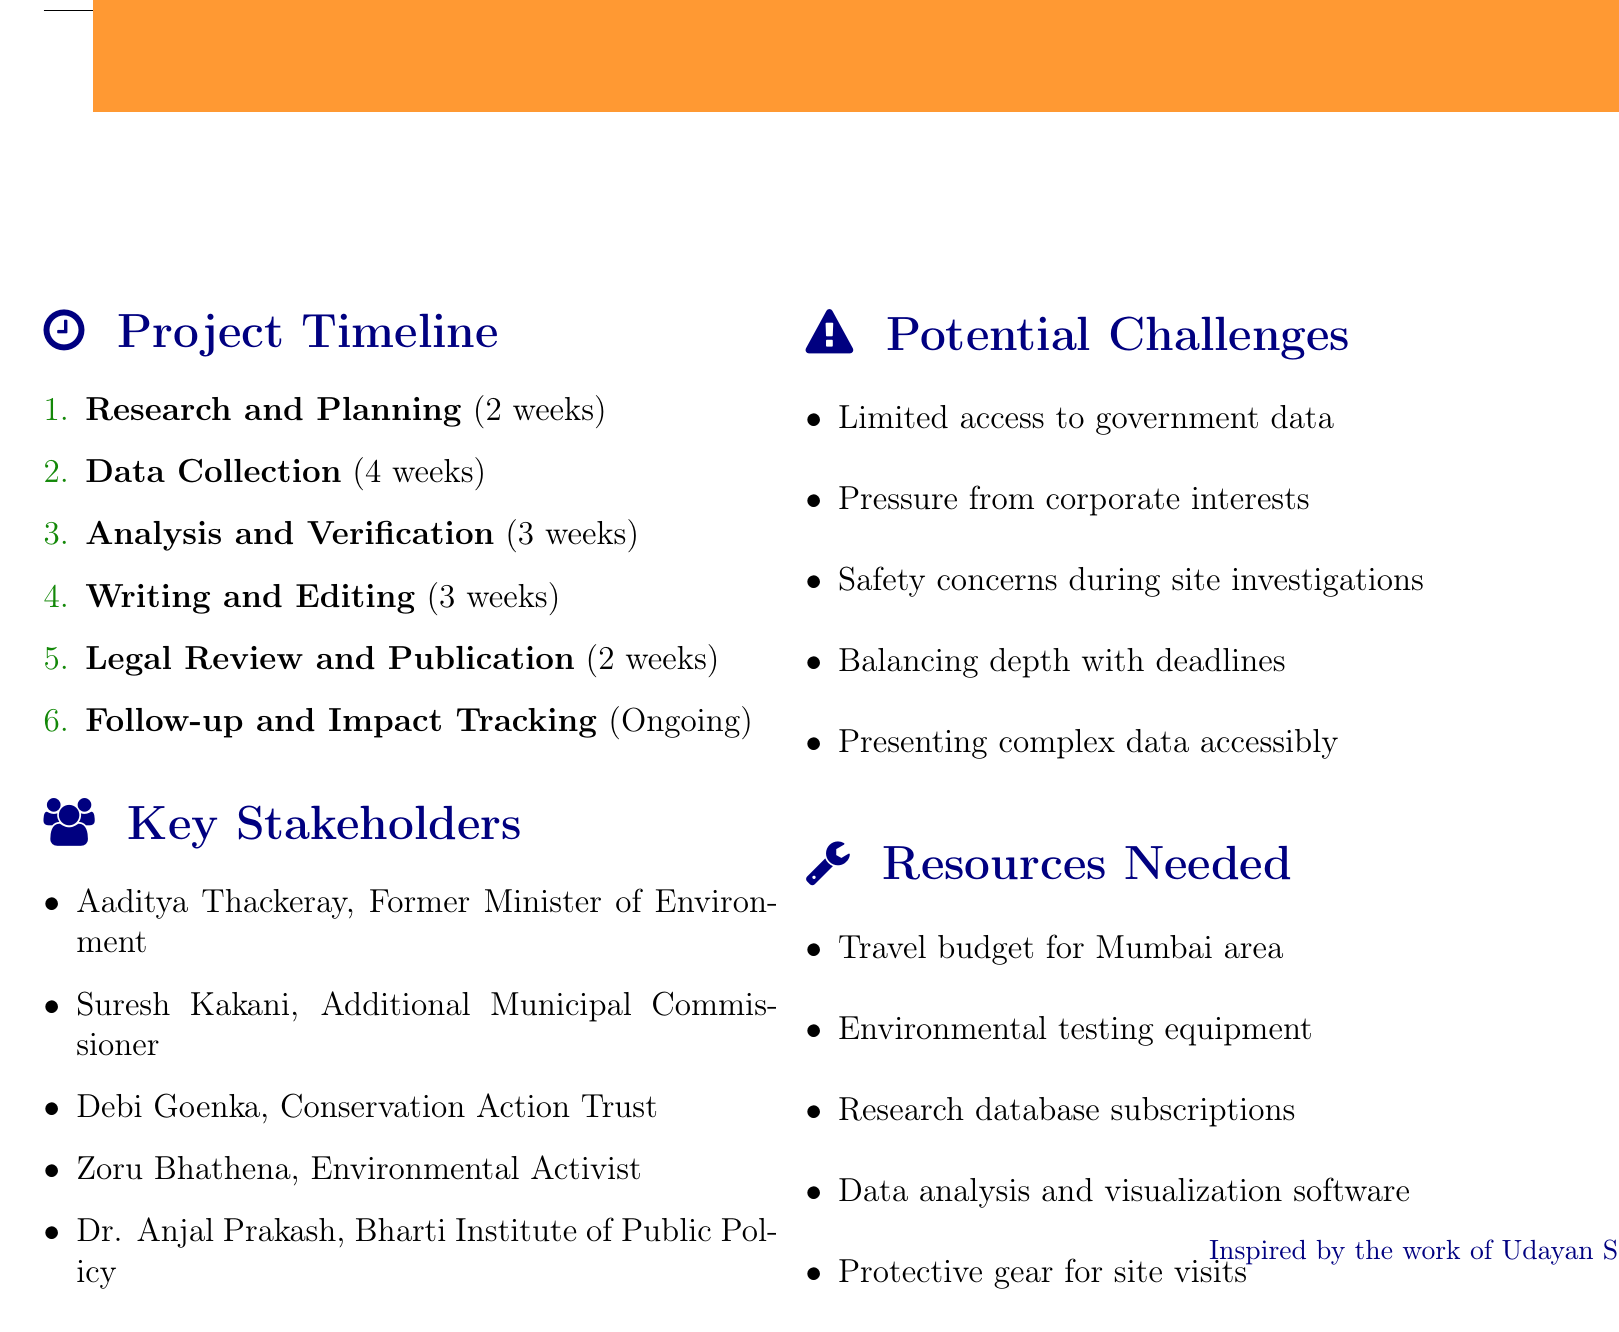what is the duration of the Research and Planning phase? The duration of the Research and Planning phase is mentioned in the document as 2 weeks.
Answer: 2 weeks how many weeks is allocated for Data Collection? The Data Collection phase is allocated 4 weeks as specified in the timeline.
Answer: 4 weeks who is a key stakeholder and an Executive Trustee of the Conservation Action Trust? The document lists Debi Goenka as a key stakeholder who is the Executive Trustee of the Conservation Action Trust.
Answer: Debi Goenka what is one potential challenge mentioned in the document? The document lists multiple potential challenges; one of them includes limited access to government data.
Answer: Limited access to government data how many tasks are involved in the Analysis and Verification phase? The document outlines 5 specific tasks involved in the Analysis and Verification phase.
Answer: 5 tasks what resource is needed for site visits as mentioned in the document? The document states that protective gear for site visits, including masks and gloves, is needed as a resource.
Answer: Protective gear who should be consulted for legal perspective during the investigation? The document specifies that environmental lawyer Ritwick Dutta should be consulted for a legal perspective.
Answer: Ritwick Dutta how long is the Follow-up and Impact Tracking phase expected to continue? The document indicates that the Follow-up and Impact Tracking phase is ongoing without a specified duration.
Answer: Ongoing 